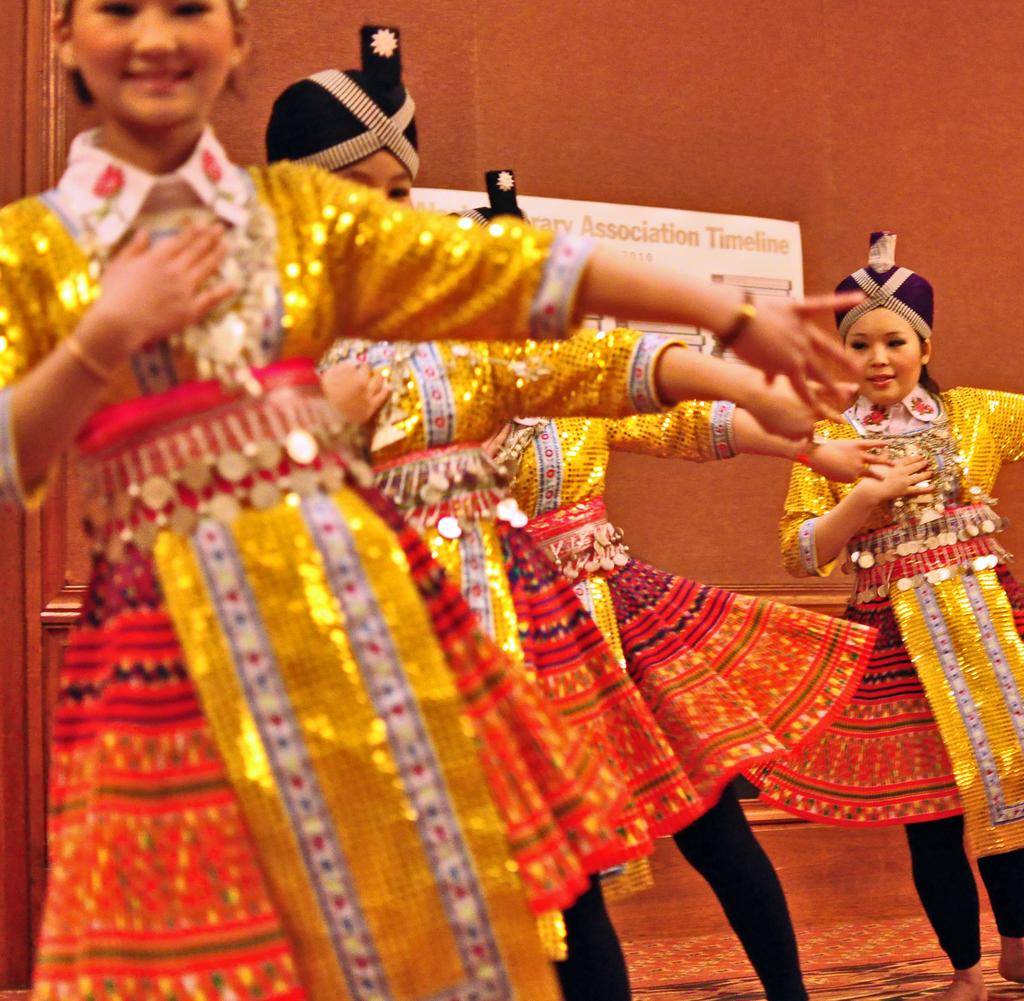How many women are in the image? There are four women in the image. What are the women wearing on their heads? The women are wearing caps. What are the women doing in the image? The women are dancing on the floor. What expression do the women have in the image? The women are smiling. What can be seen in the background of the image? There is a wall with a banner in the background of the image. What type of books can be seen on the floor while the women are dancing? There are no books visible in the image; the women are dancing on the floor without any books present. 